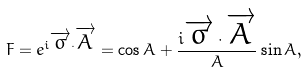Convert formula to latex. <formula><loc_0><loc_0><loc_500><loc_500>F = e ^ { i \overrightarrow { \sigma } \cdot \overrightarrow { A } } = \cos { A } + \frac { i \overrightarrow { \sigma } \cdot \overrightarrow { A } } { A } \sin { A } ,</formula> 